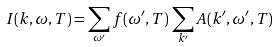<formula> <loc_0><loc_0><loc_500><loc_500>I ( k , \omega , T ) = \sum _ { \omega ^ { \prime } } f ( \omega ^ { \prime } , T ) \, \sum _ { k ^ { \prime } } A ( k ^ { \prime } , \omega ^ { \prime } , T )</formula> 